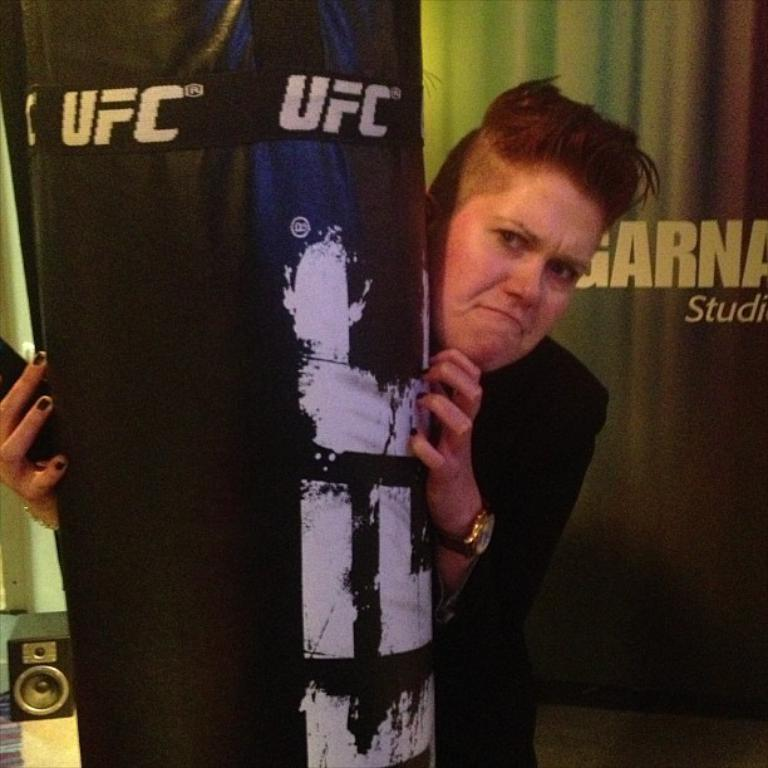<image>
Share a concise interpretation of the image provided. a woman standing behind a punching bag that says 'ufc' on it 